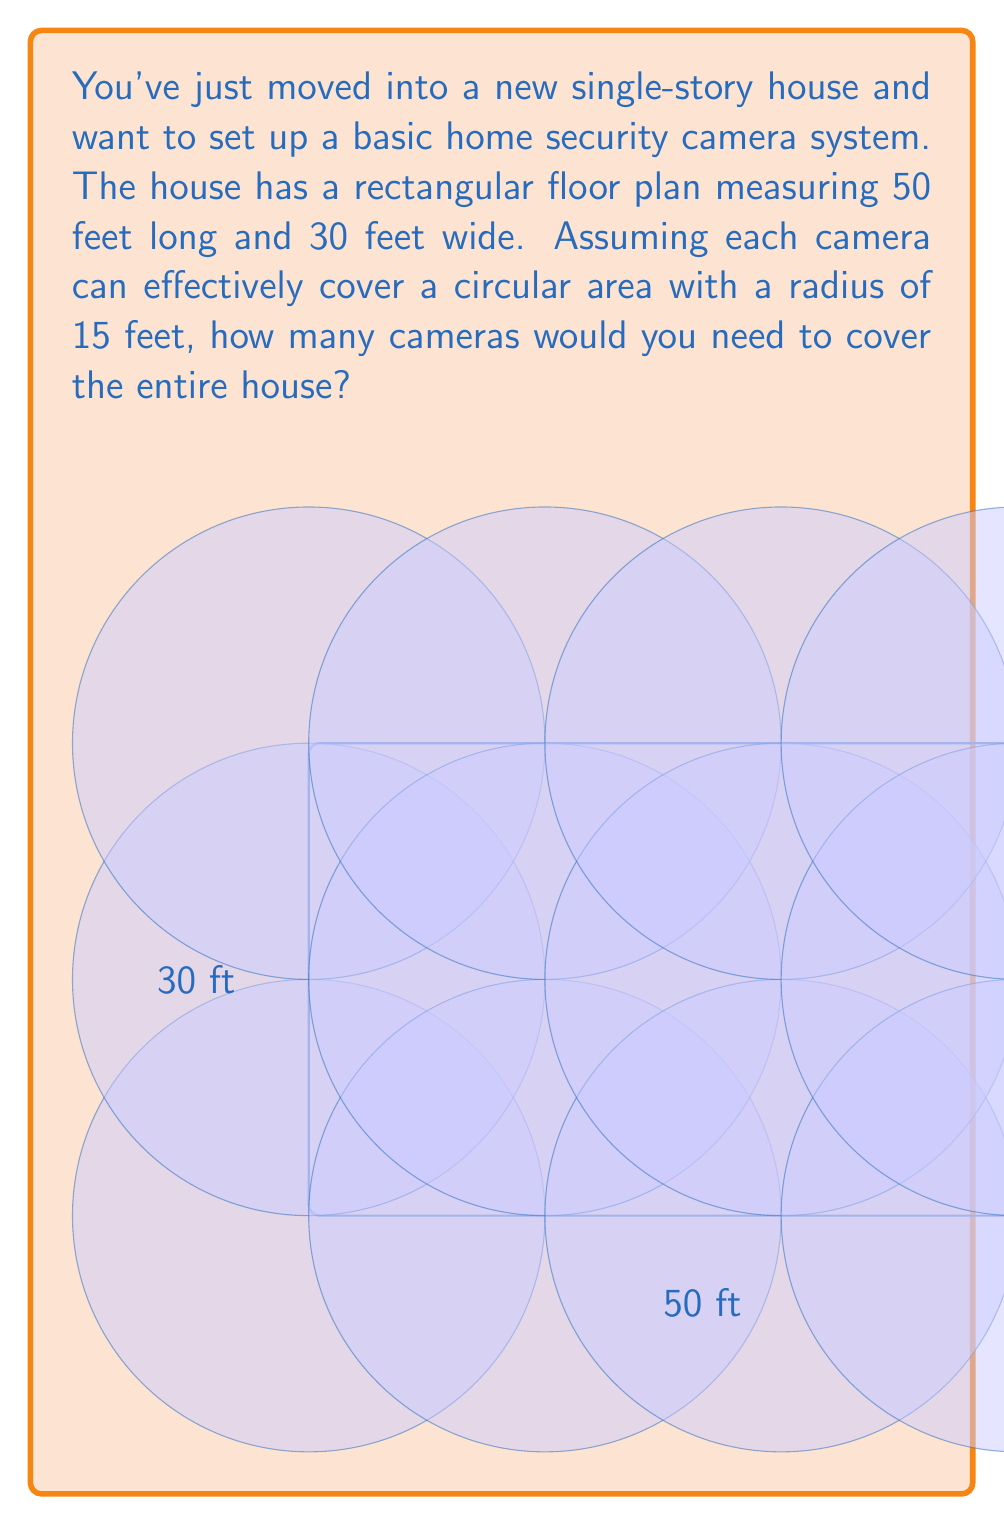What is the answer to this math problem? Let's approach this step-by-step:

1) First, we need to calculate the total area of the house:
   Area = length × width
   $$ A = 50 \text{ ft} \times 30 \text{ ft} = 1500 \text{ sq ft} $$

2) Next, we calculate the area that each camera can cover:
   Area of a circle = $\pi r^2$
   $$ A_{camera} = \pi \times (15 \text{ ft})^2 = 225\pi \approx 706.86 \text{ sq ft} $$

3) To find the number of cameras needed, we divide the total area by the area each camera covers:
   $$ \text{Number of cameras} = \frac{\text{Total area}}{\text{Area per camera}} $$
   $$ = \frac{1500 \text{ sq ft}}{706.86 \text{ sq ft}} \approx 2.12 $$

4) Since we can't use a fraction of a camera, we need to round up to the nearest whole number:
   $$ \text{Number of cameras} = \lceil 2.12 \rceil = 3 $$

5) However, this calculation assumes perfect circular coverage without overlap, which isn't realistic. In practice, you might need an extra camera to cover corners or ensure complete coverage.

Therefore, a more practical estimate would be 4 cameras to ensure full coverage of the house.
Answer: 4 cameras 